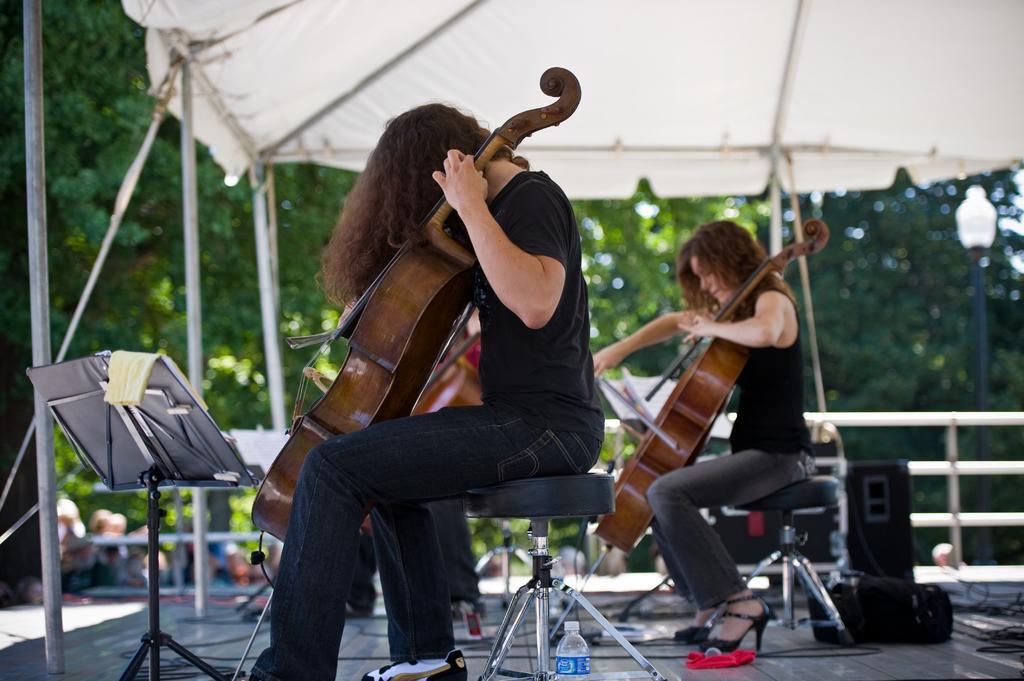How would you summarize this image in a sentence or two? This two persons are sitting on chair and playing violin. This is tent. These are trees. On floor there is a speaker and bag. Beside this person there is a bottle. This is a book stand. 